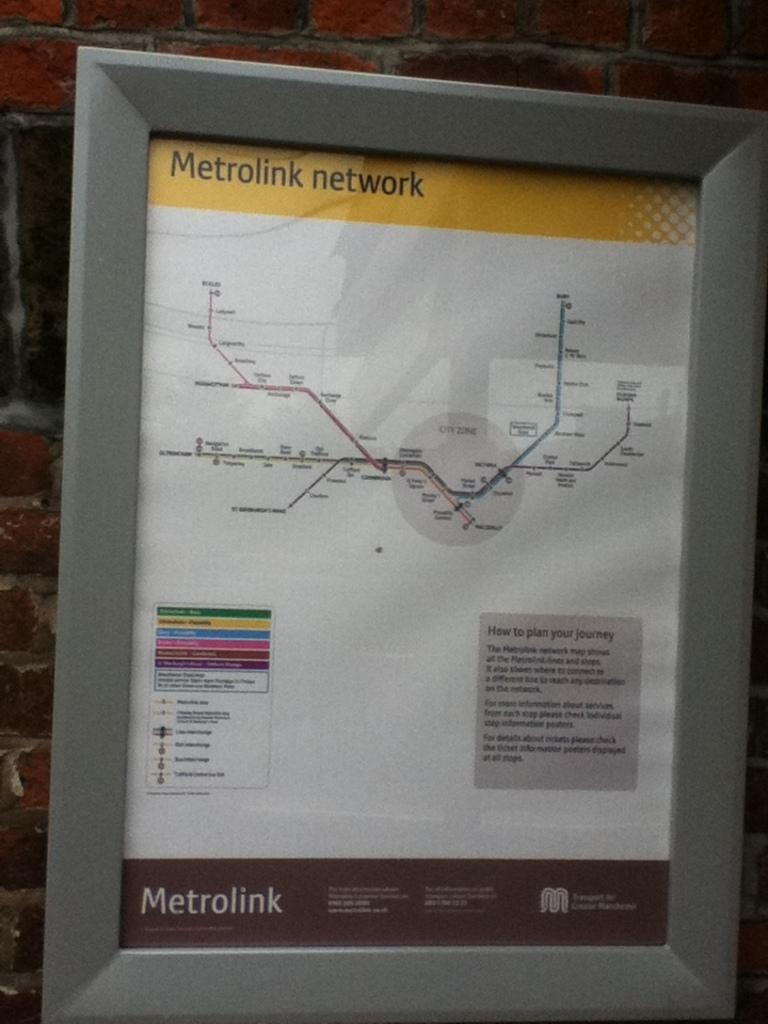Provide a one-sentence caption for the provided image. A Metrolink network map is in a grey colored frame. 